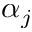Convert formula to latex. <formula><loc_0><loc_0><loc_500><loc_500>\alpha _ { j }</formula> 